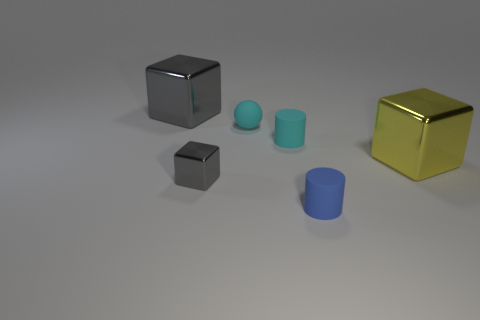Are there any small blue objects that have the same shape as the big gray thing?
Offer a very short reply. No. Is the number of tiny cyan matte things less than the number of yellow metal things?
Ensure brevity in your answer.  No. Do the big gray thing and the tiny gray thing have the same shape?
Your answer should be very brief. Yes. How many things are large brown shiny blocks or large things on the left side of the blue thing?
Ensure brevity in your answer.  1. What number of cyan rubber things are there?
Offer a terse response. 2. Are there any cyan shiny cylinders that have the same size as the yellow shiny object?
Keep it short and to the point. No. Is the number of small gray things to the left of the tiny block less than the number of big yellow metal objects?
Offer a very short reply. Yes. Do the cyan rubber cylinder and the yellow metal cube have the same size?
Your answer should be compact. No. What is the size of the other gray block that is the same material as the large gray cube?
Provide a succinct answer. Small. How many cylinders have the same color as the small metal thing?
Ensure brevity in your answer.  0. 